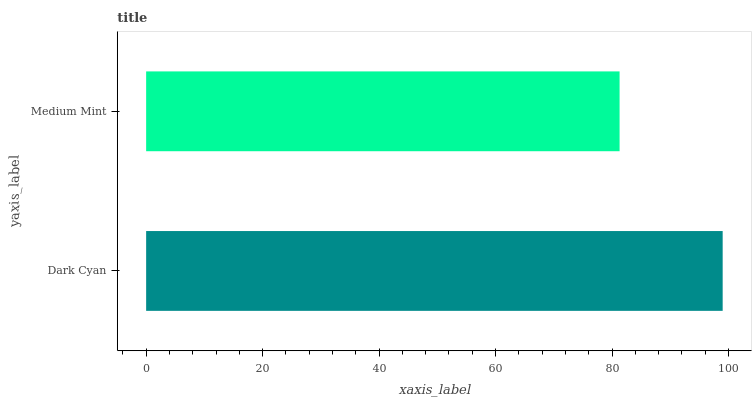Is Medium Mint the minimum?
Answer yes or no. Yes. Is Dark Cyan the maximum?
Answer yes or no. Yes. Is Medium Mint the maximum?
Answer yes or no. No. Is Dark Cyan greater than Medium Mint?
Answer yes or no. Yes. Is Medium Mint less than Dark Cyan?
Answer yes or no. Yes. Is Medium Mint greater than Dark Cyan?
Answer yes or no. No. Is Dark Cyan less than Medium Mint?
Answer yes or no. No. Is Dark Cyan the high median?
Answer yes or no. Yes. Is Medium Mint the low median?
Answer yes or no. Yes. Is Medium Mint the high median?
Answer yes or no. No. Is Dark Cyan the low median?
Answer yes or no. No. 